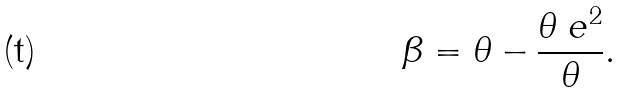<formula> <loc_0><loc_0><loc_500><loc_500>\beta = \theta - \frac { \theta _ { \ } e ^ { 2 } } { \theta } .</formula> 